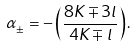Convert formula to latex. <formula><loc_0><loc_0><loc_500><loc_500>\alpha _ { \pm } = - \left ( \frac { 8 K \mp 3 l } { 4 K \mp l } \right ) .</formula> 